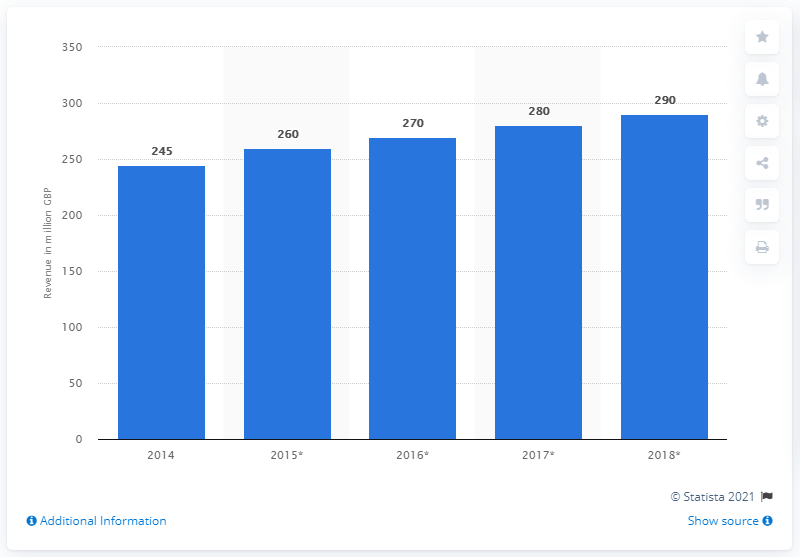Mention a couple of crucial points in this snapshot. The average value of all the bars is 269. In 2015, there was a significant increase in revenue compared to previous years. In 2014, the revenue generated was 245... 